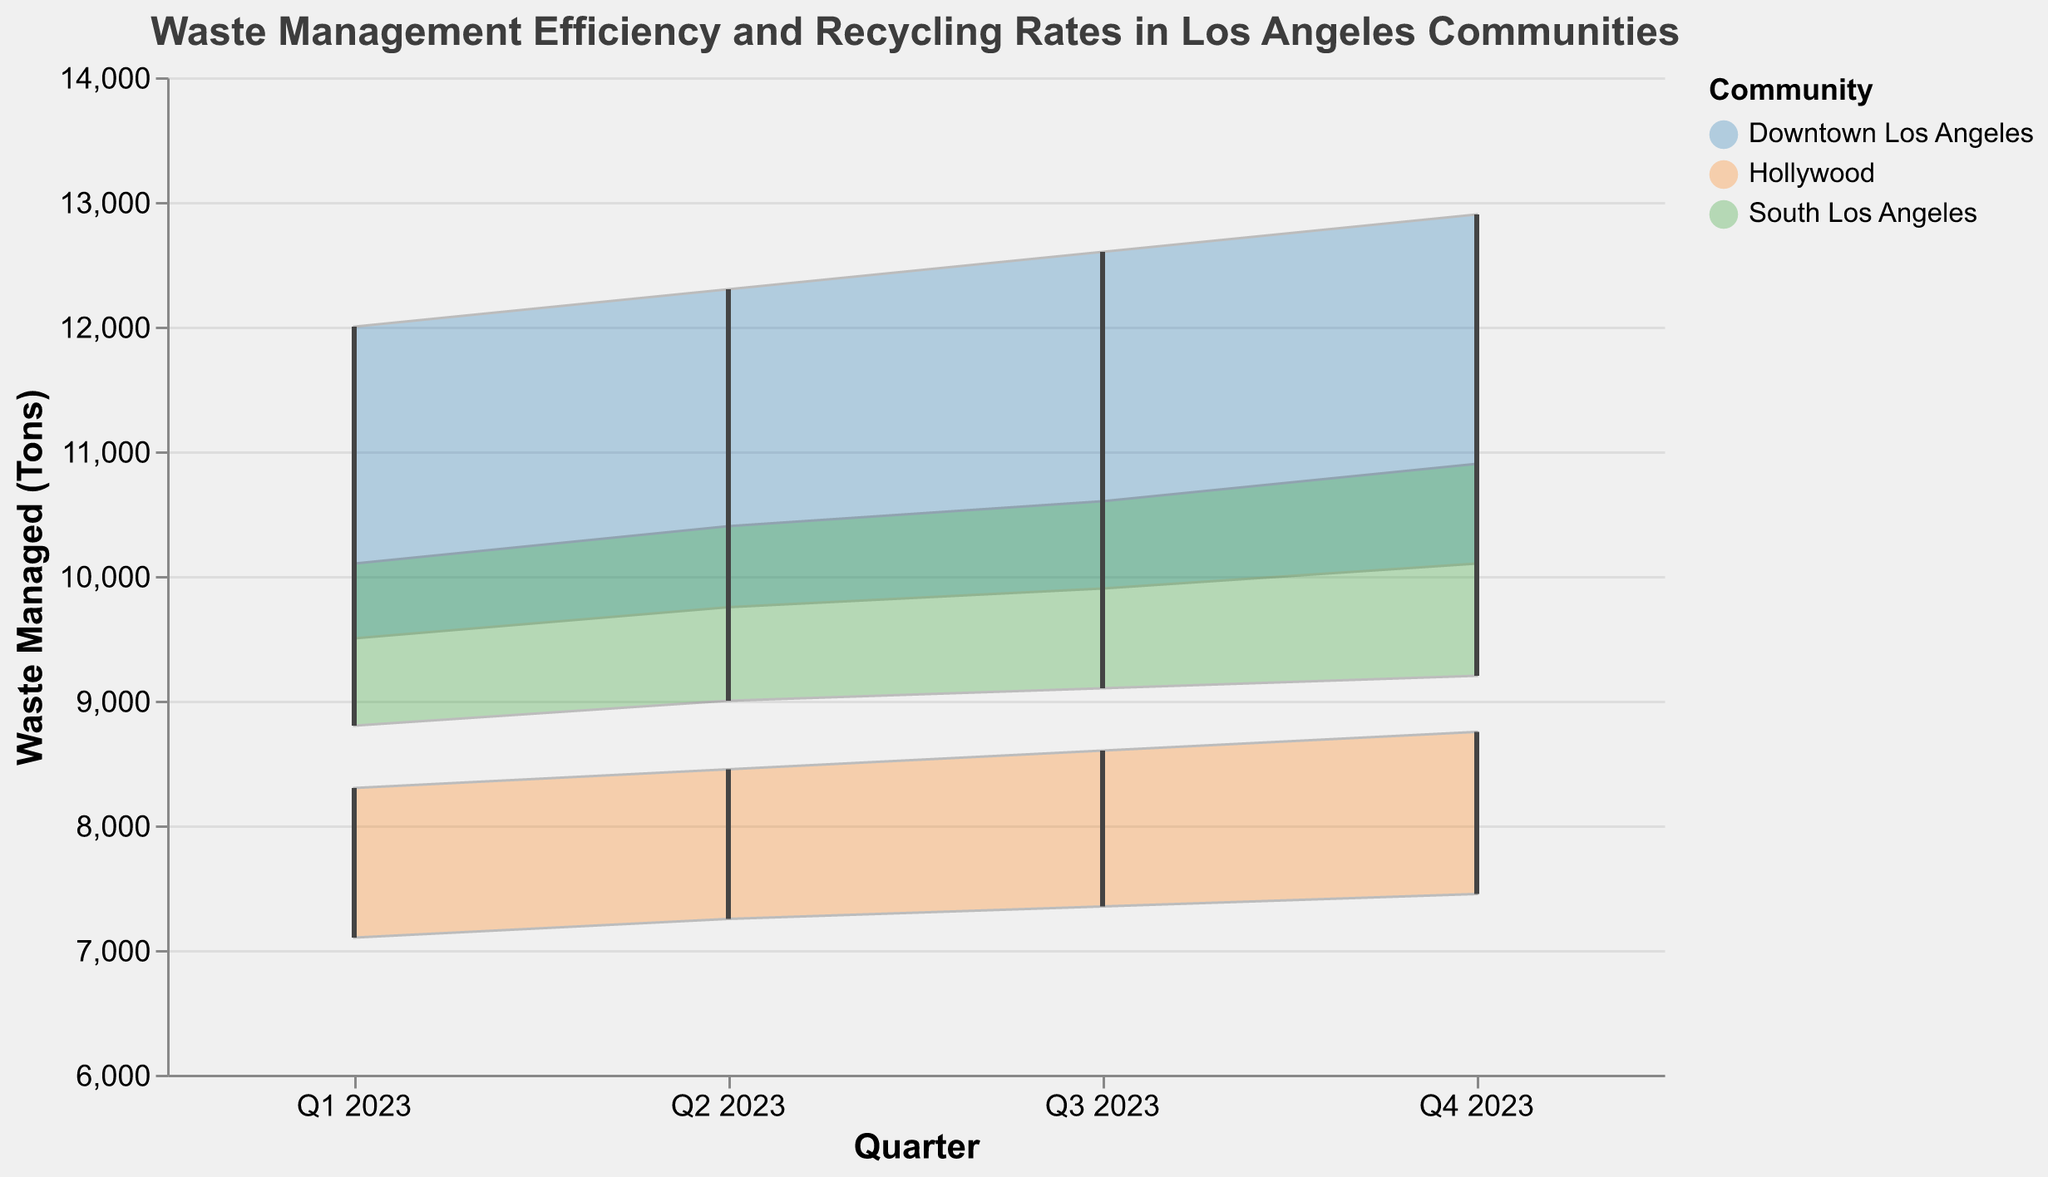what is the title of the chart? The title of the chart is displayed at the top center of the figure.
Answer: Waste Management Efficiency and Recycling Rates in Los Angeles Communities Which community handled the most waste in Q1 2023? To determine this, look at the highest point for waste managed in Q1 2023 on the chart.
Answer: Downtown Los Angeles How did the recycling rate range change in South Los Angeles from Q1 2023 to Q4 2023? Compare the highest and lowest recycling rates for South Los Angeles in Q1 2023 with those in Q4 2023. In Q1 2023, the range was 40% to 50%, and in Q4 2023, the range was 46% to 56%.
Answer: Increased from 40%-50% to 46%-56% What is the trend in waste management for Downtown Los Angeles across the quarters? Observe the trend lines for Downtown Los Angeles in terms of waste managed in tons from Q1 to Q4 2023.
Answer: Increasing In which quarter did Hollywood have its highest minimum waste managed? Identify the quarter with the highest "Waste Managed Tons Low" value for Hollywood. Q4 2023 has the highest minimum waste managed for Hollywood at 7450 tons.
Answer: Q4 2023 What is the average high recycling rate for Downtown Los Angeles in 2023? Calculate the average of the high recycling rates for Downtown Los Angeles in 2023: (60 + 62 + 64 + 65) / 4 = 62.75%.
Answer: 62.75% Compare the recycling rate range for Hollywood and South Los Angeles in Q3 2023. In Q3 2023, Hollywood's recycling rate range is 48% to 58%, while South Los Angeles' range is 44% to 54%.
Answer: Hollywood: 48%-58%, South Los Angeles: 44%-54% Which community had the smallest gap between high and low waste managed in Q4 2023? To find this, calculate the differences between high and low waste managed for each community in Q4 2023. Hollywood had the smallest gap: 8750 - 7450 = 1300 tons.
Answer: Hollywood How does the waste managed in South Los Angeles in Q2 2023 compare to Q1 2023? Compare the "Waste Managed Tons High" and "Waste Managed Tons Low" for South Los Angeles in both quarters. Q2 2023 has higher values: 10400 tons (high) and 9000 tons (low) compared to Q1 2023 values of 10100 tons (high) and 8800 tons (low).
Answer: Increased By how much did the high recycling rate increase in Hollywood from Q1 2023 to Q4 2023? Subtract the high recycling rate of Q1 2023 from that of Q4 2023 for Hollywood. 60% - 55% = 5%.
Answer: 5% 